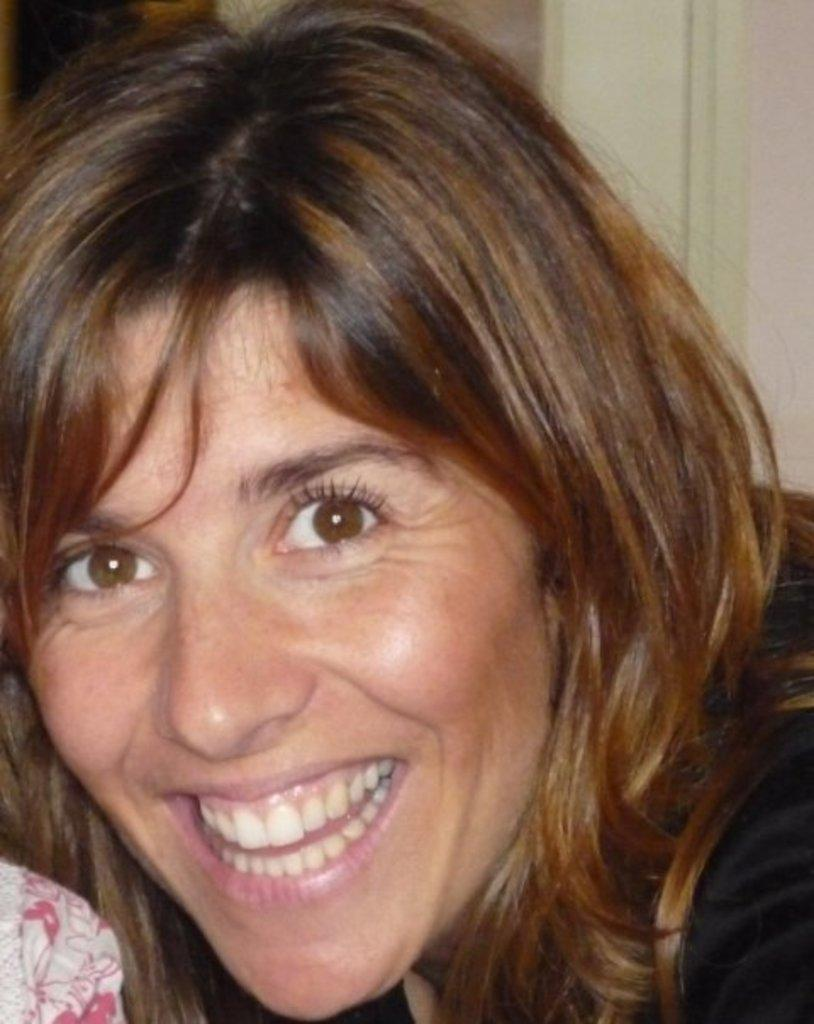Who is present in the image? There is a woman in the image. What is the woman doing in the image? The woman is laughing. What can be seen behind the woman in the image? There is a wall behind the woman. How many snails are crawling on the woman's shoulder in the image? There are no snails present in the image. What is the woman's level of wealth based on the image? The image does not provide any information about the woman's wealth. 